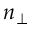<formula> <loc_0><loc_0><loc_500><loc_500>n _ { \perp }</formula> 